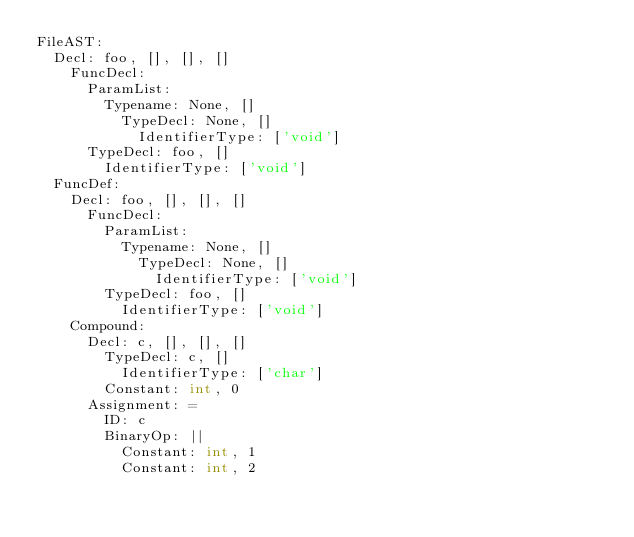Convert code to text. <code><loc_0><loc_0><loc_500><loc_500><_C_>FileAST: 
  Decl: foo, [], [], []
    FuncDecl: 
      ParamList: 
        Typename: None, []
          TypeDecl: None, []
            IdentifierType: ['void']
      TypeDecl: foo, []
        IdentifierType: ['void']
  FuncDef: 
    Decl: foo, [], [], []
      FuncDecl: 
        ParamList: 
          Typename: None, []
            TypeDecl: None, []
              IdentifierType: ['void']
        TypeDecl: foo, []
          IdentifierType: ['void']
    Compound: 
      Decl: c, [], [], []
        TypeDecl: c, []
          IdentifierType: ['char']
        Constant: int, 0
      Assignment: =
        ID: c
        BinaryOp: ||
          Constant: int, 1
          Constant: int, 2
</code> 